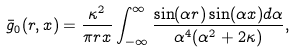Convert formula to latex. <formula><loc_0><loc_0><loc_500><loc_500>\bar { g } _ { 0 } ( r , x ) = \frac { \kappa ^ { 2 } } { \pi r x } \int _ { - \infty } ^ { \infty } \frac { \sin ( \alpha r ) \sin ( \alpha x ) d \alpha } { \alpha ^ { 4 } ( \alpha ^ { 2 } + 2 \kappa ) } ,</formula> 